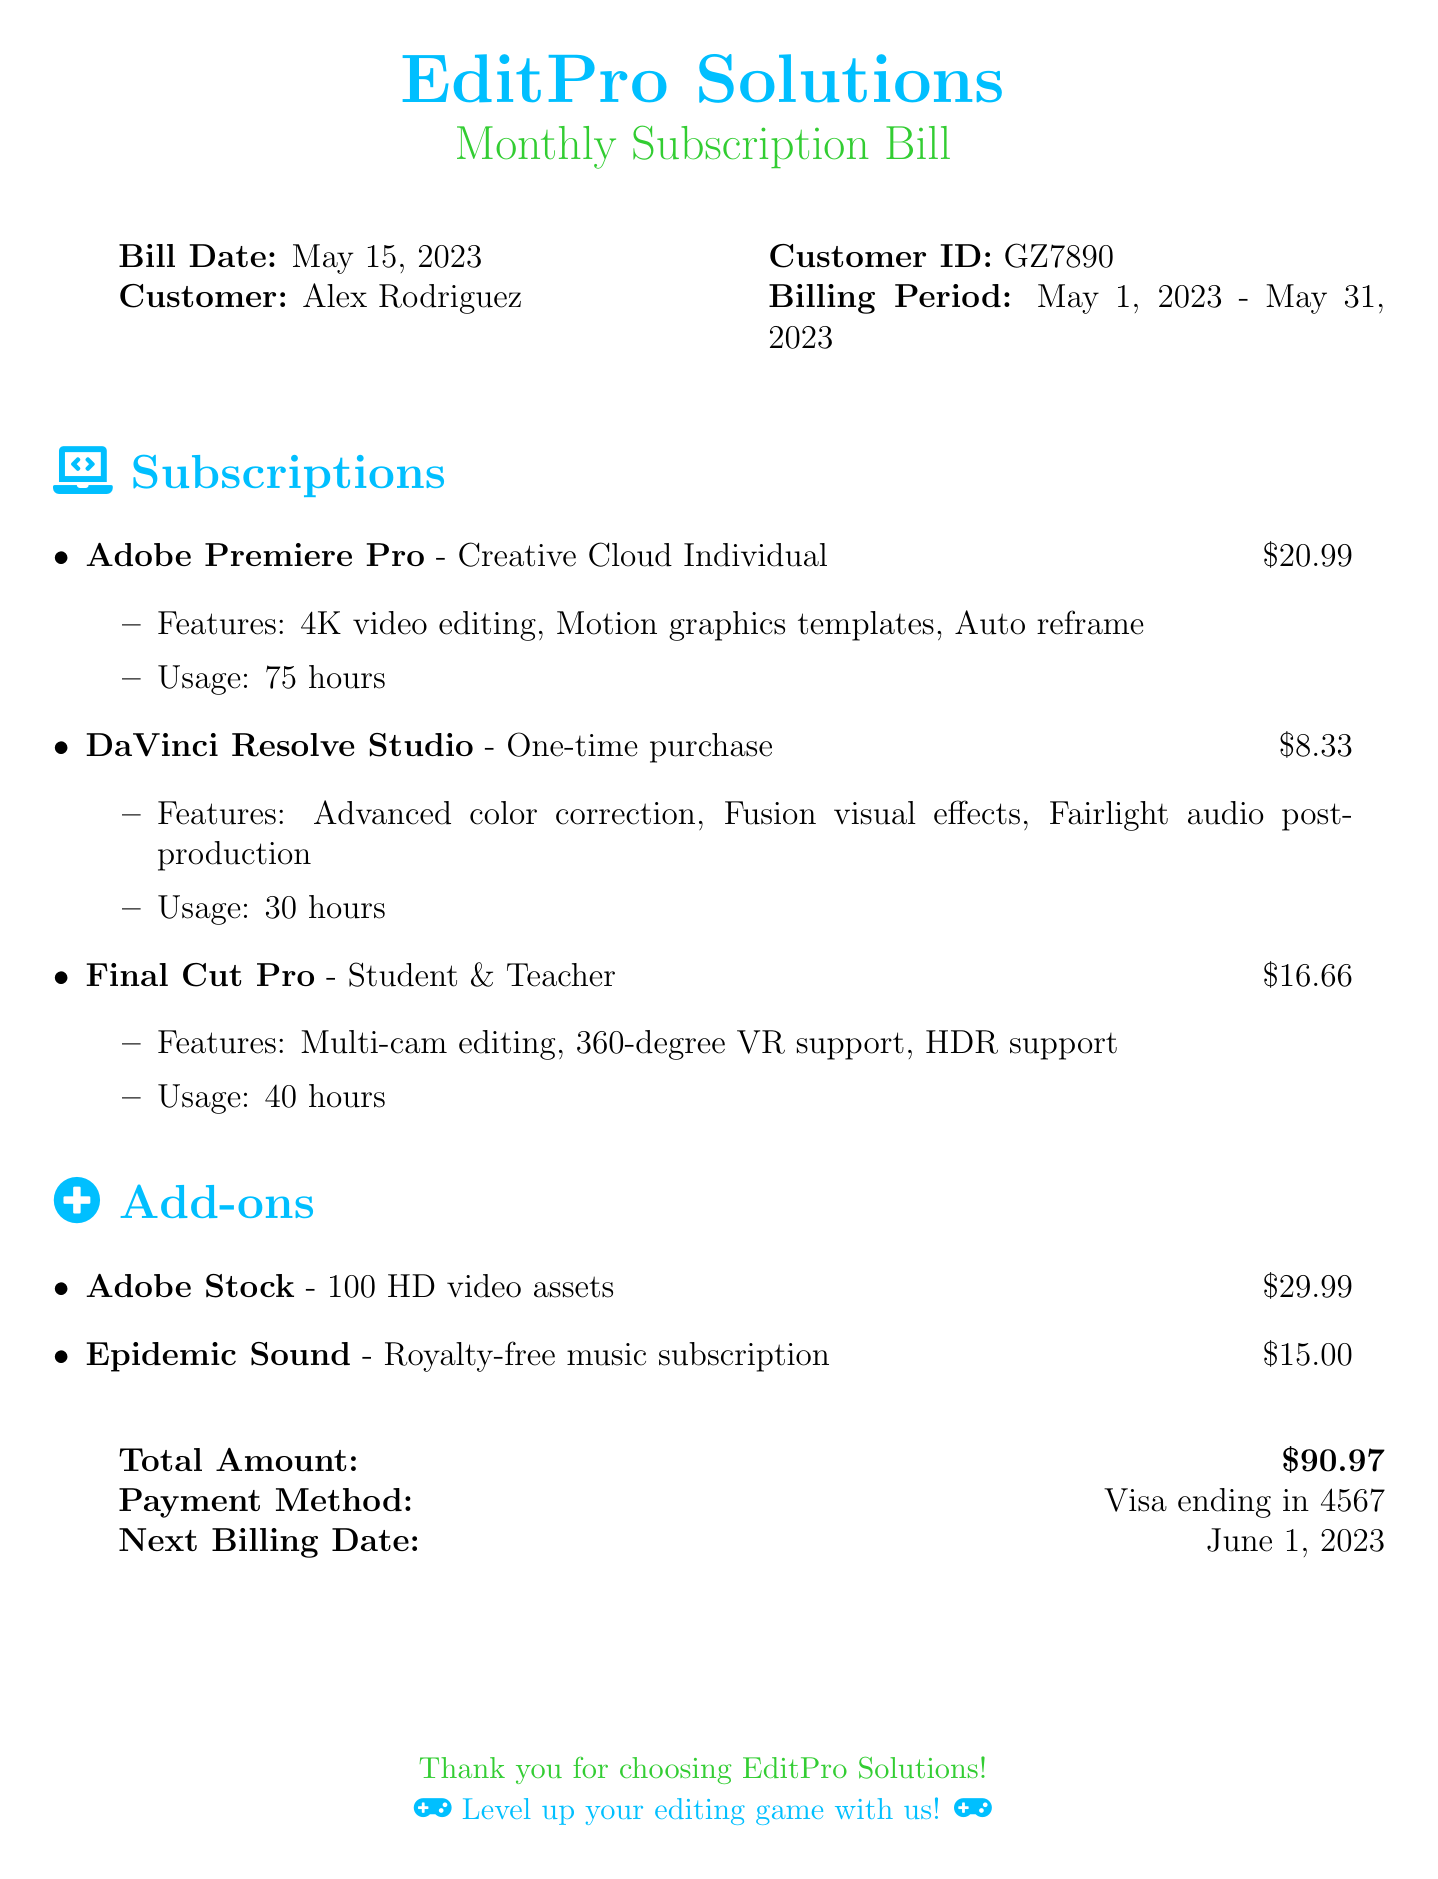What is the bill date? The bill date is clearly stated in the document.
Answer: May 15, 2023 How many hours of Adobe Premiere Pro were used? The usage for Adobe Premiere Pro is provided in the features section.
Answer: 75 hours What is the total amount due? The total amount is specified at the end of the document in a dedicated section.
Answer: $90.97 Which payment method was used? The payment method is explicitly mentioned in the billing summary.
Answer: Visa ending in 4567 What add-on provides royalty-free music? The add-ons section lists the available add-ons with their descriptions.
Answer: Epidemic Sound Which video editing software has a one-time purchase? Comparing the software types in the subscriptions section reveals this detail.
Answer: DaVinci Resolve Studio What are the features of Final Cut Pro? The features are listed directly under the Final Cut Pro subscription item.
Answer: Multi-cam editing, 360-degree VR support, HDR support What is the next billing date? This information is included in the billing summary section.
Answer: June 1, 2023 How many HD video assets does Adobe Stock provide? The number of assets included in the Adobe Stock subscription is specified.
Answer: 100 HD video assets 